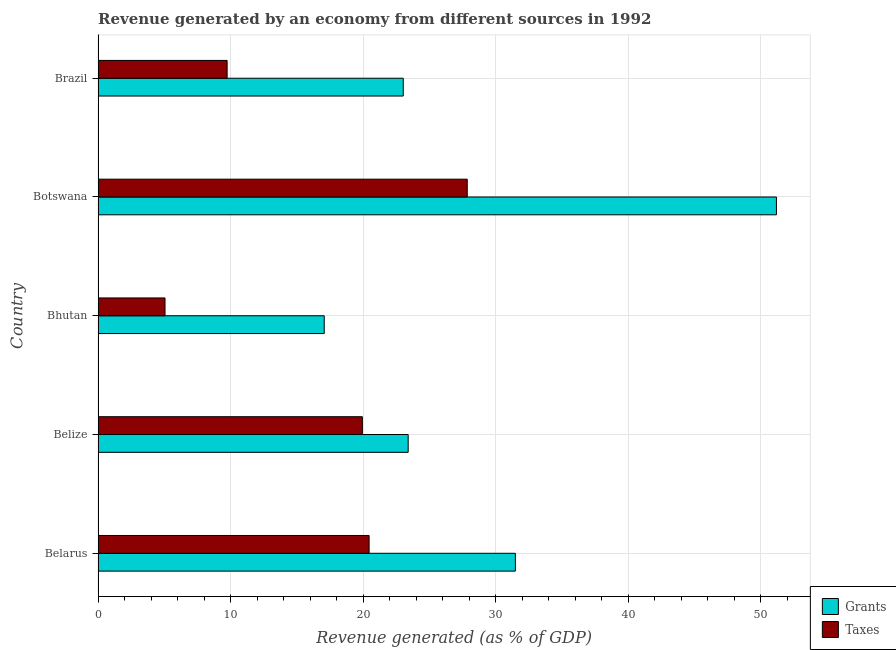How many different coloured bars are there?
Provide a short and direct response. 2. How many bars are there on the 3rd tick from the bottom?
Make the answer very short. 2. What is the label of the 3rd group of bars from the top?
Give a very brief answer. Bhutan. In how many cases, is the number of bars for a given country not equal to the number of legend labels?
Give a very brief answer. 0. What is the revenue generated by grants in Belarus?
Keep it short and to the point. 31.48. Across all countries, what is the maximum revenue generated by taxes?
Your response must be concise. 27.85. Across all countries, what is the minimum revenue generated by grants?
Give a very brief answer. 17.06. In which country was the revenue generated by grants maximum?
Provide a succinct answer. Botswana. In which country was the revenue generated by taxes minimum?
Give a very brief answer. Bhutan. What is the total revenue generated by grants in the graph?
Make the answer very short. 146.11. What is the difference between the revenue generated by grants in Belarus and that in Botswana?
Offer a very short reply. -19.69. What is the difference between the revenue generated by grants in Brazil and the revenue generated by taxes in Belize?
Provide a succinct answer. 3.09. What is the average revenue generated by grants per country?
Offer a very short reply. 29.22. What is the difference between the revenue generated by grants and revenue generated by taxes in Belarus?
Your response must be concise. 11.03. In how many countries, is the revenue generated by grants greater than 14 %?
Give a very brief answer. 5. What is the ratio of the revenue generated by grants in Belarus to that in Belize?
Offer a terse response. 1.35. Is the revenue generated by grants in Belize less than that in Botswana?
Keep it short and to the point. Yes. Is the difference between the revenue generated by taxes in Bhutan and Brazil greater than the difference between the revenue generated by grants in Bhutan and Brazil?
Provide a succinct answer. Yes. What is the difference between the highest and the second highest revenue generated by taxes?
Your answer should be very brief. 7.4. What is the difference between the highest and the lowest revenue generated by taxes?
Your answer should be very brief. 22.8. What does the 1st bar from the top in Bhutan represents?
Give a very brief answer. Taxes. What does the 2nd bar from the bottom in Belarus represents?
Provide a succinct answer. Taxes. How many countries are there in the graph?
Your response must be concise. 5. What is the difference between two consecutive major ticks on the X-axis?
Offer a terse response. 10. How are the legend labels stacked?
Make the answer very short. Vertical. What is the title of the graph?
Give a very brief answer. Revenue generated by an economy from different sources in 1992. What is the label or title of the X-axis?
Give a very brief answer. Revenue generated (as % of GDP). What is the Revenue generated (as % of GDP) in Grants in Belarus?
Your response must be concise. 31.48. What is the Revenue generated (as % of GDP) of Taxes in Belarus?
Your answer should be compact. 20.44. What is the Revenue generated (as % of GDP) of Grants in Belize?
Provide a short and direct response. 23.39. What is the Revenue generated (as % of GDP) in Taxes in Belize?
Your response must be concise. 19.94. What is the Revenue generated (as % of GDP) in Grants in Bhutan?
Keep it short and to the point. 17.06. What is the Revenue generated (as % of GDP) in Taxes in Bhutan?
Provide a succinct answer. 5.05. What is the Revenue generated (as % of GDP) of Grants in Botswana?
Your response must be concise. 51.17. What is the Revenue generated (as % of GDP) in Taxes in Botswana?
Your response must be concise. 27.85. What is the Revenue generated (as % of GDP) of Grants in Brazil?
Make the answer very short. 23.02. What is the Revenue generated (as % of GDP) in Taxes in Brazil?
Ensure brevity in your answer.  9.73. Across all countries, what is the maximum Revenue generated (as % of GDP) of Grants?
Offer a very short reply. 51.17. Across all countries, what is the maximum Revenue generated (as % of GDP) in Taxes?
Offer a terse response. 27.85. Across all countries, what is the minimum Revenue generated (as % of GDP) in Grants?
Provide a succinct answer. 17.06. Across all countries, what is the minimum Revenue generated (as % of GDP) of Taxes?
Provide a succinct answer. 5.05. What is the total Revenue generated (as % of GDP) of Grants in the graph?
Your response must be concise. 146.11. What is the total Revenue generated (as % of GDP) in Taxes in the graph?
Your answer should be very brief. 83.01. What is the difference between the Revenue generated (as % of GDP) in Grants in Belarus and that in Belize?
Give a very brief answer. 8.09. What is the difference between the Revenue generated (as % of GDP) in Taxes in Belarus and that in Belize?
Ensure brevity in your answer.  0.51. What is the difference between the Revenue generated (as % of GDP) of Grants in Belarus and that in Bhutan?
Keep it short and to the point. 14.42. What is the difference between the Revenue generated (as % of GDP) of Taxes in Belarus and that in Bhutan?
Provide a succinct answer. 15.39. What is the difference between the Revenue generated (as % of GDP) of Grants in Belarus and that in Botswana?
Your answer should be compact. -19.69. What is the difference between the Revenue generated (as % of GDP) of Taxes in Belarus and that in Botswana?
Offer a very short reply. -7.4. What is the difference between the Revenue generated (as % of GDP) in Grants in Belarus and that in Brazil?
Keep it short and to the point. 8.46. What is the difference between the Revenue generated (as % of GDP) in Taxes in Belarus and that in Brazil?
Make the answer very short. 10.71. What is the difference between the Revenue generated (as % of GDP) in Grants in Belize and that in Bhutan?
Offer a very short reply. 6.33. What is the difference between the Revenue generated (as % of GDP) in Taxes in Belize and that in Bhutan?
Keep it short and to the point. 14.89. What is the difference between the Revenue generated (as % of GDP) of Grants in Belize and that in Botswana?
Give a very brief answer. -27.78. What is the difference between the Revenue generated (as % of GDP) of Taxes in Belize and that in Botswana?
Ensure brevity in your answer.  -7.91. What is the difference between the Revenue generated (as % of GDP) of Grants in Belize and that in Brazil?
Provide a short and direct response. 0.37. What is the difference between the Revenue generated (as % of GDP) in Taxes in Belize and that in Brazil?
Make the answer very short. 10.2. What is the difference between the Revenue generated (as % of GDP) in Grants in Bhutan and that in Botswana?
Your response must be concise. -34.11. What is the difference between the Revenue generated (as % of GDP) of Taxes in Bhutan and that in Botswana?
Your response must be concise. -22.8. What is the difference between the Revenue generated (as % of GDP) of Grants in Bhutan and that in Brazil?
Offer a very short reply. -5.96. What is the difference between the Revenue generated (as % of GDP) in Taxes in Bhutan and that in Brazil?
Offer a terse response. -4.68. What is the difference between the Revenue generated (as % of GDP) in Grants in Botswana and that in Brazil?
Give a very brief answer. 28.15. What is the difference between the Revenue generated (as % of GDP) in Taxes in Botswana and that in Brazil?
Give a very brief answer. 18.11. What is the difference between the Revenue generated (as % of GDP) in Grants in Belarus and the Revenue generated (as % of GDP) in Taxes in Belize?
Ensure brevity in your answer.  11.54. What is the difference between the Revenue generated (as % of GDP) of Grants in Belarus and the Revenue generated (as % of GDP) of Taxes in Bhutan?
Your response must be concise. 26.43. What is the difference between the Revenue generated (as % of GDP) of Grants in Belarus and the Revenue generated (as % of GDP) of Taxes in Botswana?
Keep it short and to the point. 3.63. What is the difference between the Revenue generated (as % of GDP) in Grants in Belarus and the Revenue generated (as % of GDP) in Taxes in Brazil?
Offer a very short reply. 21.74. What is the difference between the Revenue generated (as % of GDP) of Grants in Belize and the Revenue generated (as % of GDP) of Taxes in Bhutan?
Keep it short and to the point. 18.34. What is the difference between the Revenue generated (as % of GDP) in Grants in Belize and the Revenue generated (as % of GDP) in Taxes in Botswana?
Give a very brief answer. -4.46. What is the difference between the Revenue generated (as % of GDP) of Grants in Belize and the Revenue generated (as % of GDP) of Taxes in Brazil?
Offer a terse response. 13.66. What is the difference between the Revenue generated (as % of GDP) in Grants in Bhutan and the Revenue generated (as % of GDP) in Taxes in Botswana?
Ensure brevity in your answer.  -10.79. What is the difference between the Revenue generated (as % of GDP) in Grants in Bhutan and the Revenue generated (as % of GDP) in Taxes in Brazil?
Your response must be concise. 7.32. What is the difference between the Revenue generated (as % of GDP) in Grants in Botswana and the Revenue generated (as % of GDP) in Taxes in Brazil?
Offer a terse response. 41.44. What is the average Revenue generated (as % of GDP) in Grants per country?
Provide a short and direct response. 29.22. What is the average Revenue generated (as % of GDP) of Taxes per country?
Provide a short and direct response. 16.6. What is the difference between the Revenue generated (as % of GDP) in Grants and Revenue generated (as % of GDP) in Taxes in Belarus?
Give a very brief answer. 11.03. What is the difference between the Revenue generated (as % of GDP) in Grants and Revenue generated (as % of GDP) in Taxes in Belize?
Make the answer very short. 3.45. What is the difference between the Revenue generated (as % of GDP) in Grants and Revenue generated (as % of GDP) in Taxes in Bhutan?
Offer a terse response. 12.01. What is the difference between the Revenue generated (as % of GDP) of Grants and Revenue generated (as % of GDP) of Taxes in Botswana?
Provide a short and direct response. 23.32. What is the difference between the Revenue generated (as % of GDP) of Grants and Revenue generated (as % of GDP) of Taxes in Brazil?
Your answer should be very brief. 13.29. What is the ratio of the Revenue generated (as % of GDP) in Grants in Belarus to that in Belize?
Ensure brevity in your answer.  1.35. What is the ratio of the Revenue generated (as % of GDP) in Taxes in Belarus to that in Belize?
Ensure brevity in your answer.  1.03. What is the ratio of the Revenue generated (as % of GDP) of Grants in Belarus to that in Bhutan?
Provide a short and direct response. 1.85. What is the ratio of the Revenue generated (as % of GDP) of Taxes in Belarus to that in Bhutan?
Your answer should be compact. 4.05. What is the ratio of the Revenue generated (as % of GDP) in Grants in Belarus to that in Botswana?
Your answer should be very brief. 0.62. What is the ratio of the Revenue generated (as % of GDP) in Taxes in Belarus to that in Botswana?
Give a very brief answer. 0.73. What is the ratio of the Revenue generated (as % of GDP) of Grants in Belarus to that in Brazil?
Your answer should be compact. 1.37. What is the ratio of the Revenue generated (as % of GDP) of Taxes in Belarus to that in Brazil?
Your answer should be very brief. 2.1. What is the ratio of the Revenue generated (as % of GDP) of Grants in Belize to that in Bhutan?
Provide a succinct answer. 1.37. What is the ratio of the Revenue generated (as % of GDP) in Taxes in Belize to that in Bhutan?
Make the answer very short. 3.95. What is the ratio of the Revenue generated (as % of GDP) of Grants in Belize to that in Botswana?
Your response must be concise. 0.46. What is the ratio of the Revenue generated (as % of GDP) in Taxes in Belize to that in Botswana?
Provide a short and direct response. 0.72. What is the ratio of the Revenue generated (as % of GDP) of Grants in Belize to that in Brazil?
Give a very brief answer. 1.02. What is the ratio of the Revenue generated (as % of GDP) in Taxes in Belize to that in Brazil?
Provide a short and direct response. 2.05. What is the ratio of the Revenue generated (as % of GDP) in Grants in Bhutan to that in Botswana?
Keep it short and to the point. 0.33. What is the ratio of the Revenue generated (as % of GDP) of Taxes in Bhutan to that in Botswana?
Ensure brevity in your answer.  0.18. What is the ratio of the Revenue generated (as % of GDP) in Grants in Bhutan to that in Brazil?
Keep it short and to the point. 0.74. What is the ratio of the Revenue generated (as % of GDP) of Taxes in Bhutan to that in Brazil?
Give a very brief answer. 0.52. What is the ratio of the Revenue generated (as % of GDP) in Grants in Botswana to that in Brazil?
Your response must be concise. 2.22. What is the ratio of the Revenue generated (as % of GDP) of Taxes in Botswana to that in Brazil?
Offer a very short reply. 2.86. What is the difference between the highest and the second highest Revenue generated (as % of GDP) in Grants?
Your response must be concise. 19.69. What is the difference between the highest and the second highest Revenue generated (as % of GDP) in Taxes?
Give a very brief answer. 7.4. What is the difference between the highest and the lowest Revenue generated (as % of GDP) in Grants?
Your answer should be very brief. 34.11. What is the difference between the highest and the lowest Revenue generated (as % of GDP) in Taxes?
Make the answer very short. 22.8. 